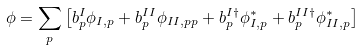Convert formula to latex. <formula><loc_0><loc_0><loc_500><loc_500>\phi = \sum _ { p } \left [ b ^ { I } _ { p } \phi _ { I , p } + b ^ { I I } _ { p } \phi _ { I I , p p } + b ^ { I \dagger } _ { p } \phi ^ { * } _ { I , p } + b ^ { I I \dagger } _ { p } \phi ^ { * } _ { I I , p } \right ]</formula> 